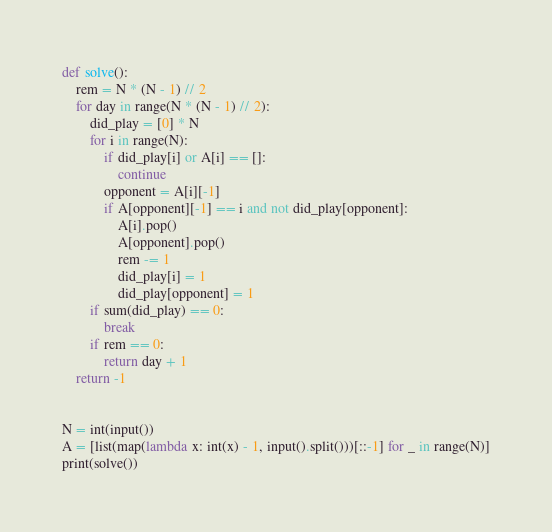<code> <loc_0><loc_0><loc_500><loc_500><_Python_>def solve():
    rem = N * (N - 1) // 2
    for day in range(N * (N - 1) // 2):
        did_play = [0] * N
        for i in range(N):
            if did_play[i] or A[i] == []:
                continue
            opponent = A[i][-1]
            if A[opponent][-1] == i and not did_play[opponent]:
                A[i].pop()
                A[opponent].pop()
                rem -= 1
                did_play[i] = 1
                did_play[opponent] = 1
        if sum(did_play) == 0:
            break
        if rem == 0:
            return day + 1
    return -1


N = int(input())
A = [list(map(lambda x: int(x) - 1, input().split()))[::-1] for _ in range(N)]
print(solve())
</code> 